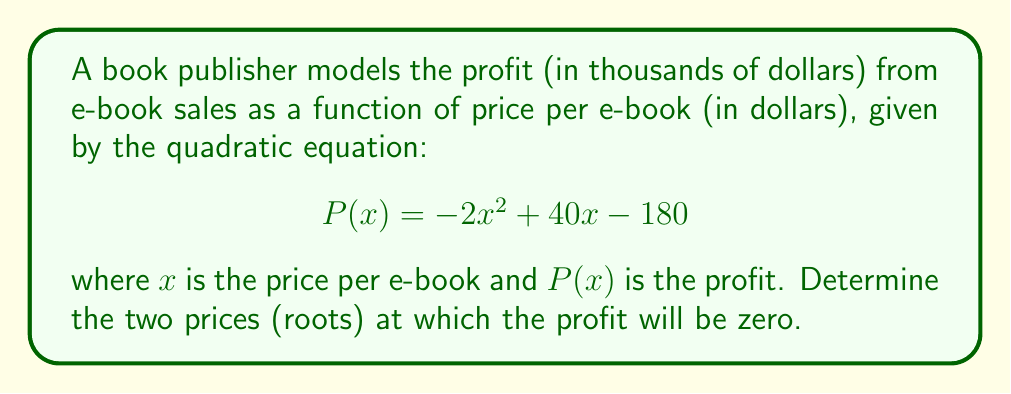Could you help me with this problem? To find the roots of this quadratic equation, we need to solve $P(x) = 0$:

1) Set the equation equal to zero:
   $$-2x^2 + 40x - 180 = 0$$

2) This is in the standard form $ax^2 + bx + c = 0$, where:
   $a = -2$, $b = 40$, and $c = -180$

3) We can use the quadratic formula: $x = \frac{-b \pm \sqrt{b^2 - 4ac}}{2a}$

4) Substituting our values:
   $$x = \frac{-40 \pm \sqrt{40^2 - 4(-2)(-180)}}{2(-2)}$$

5) Simplify under the square root:
   $$x = \frac{-40 \pm \sqrt{1600 - 1440}}{-4} = \frac{-40 \pm \sqrt{160}}{-4}$$

6) Simplify further:
   $$x = \frac{-40 \pm 4\sqrt{10}}{-4}$$

7) Divide both terms by -4:
   $$x = 10 \mp \sqrt{10}$$

8) Therefore, the two roots are:
   $$x_1 = 10 + \sqrt{10} \approx 13.16$$
   $$x_2 = 10 - \sqrt{10} \approx 6.84$$
Answer: $x_1 = 10 + \sqrt{10}$, $x_2 = 10 - \sqrt{10}$ 